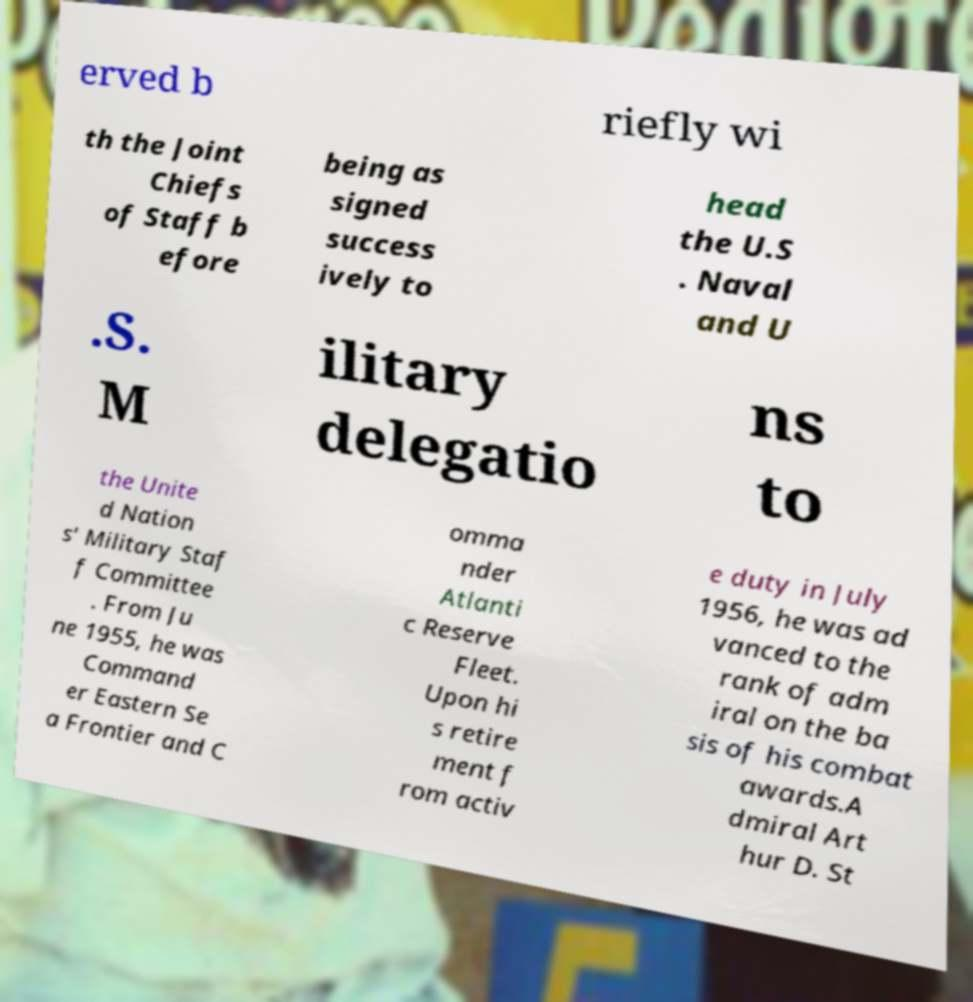Please read and relay the text visible in this image. What does it say? erved b riefly wi th the Joint Chiefs of Staff b efore being as signed success ively to head the U.S . Naval and U .S. M ilitary delegatio ns to the Unite d Nation s' Military Staf f Committee . From Ju ne 1955, he was Command er Eastern Se a Frontier and C omma nder Atlanti c Reserve Fleet. Upon hi s retire ment f rom activ e duty in July 1956, he was ad vanced to the rank of adm iral on the ba sis of his combat awards.A dmiral Art hur D. St 